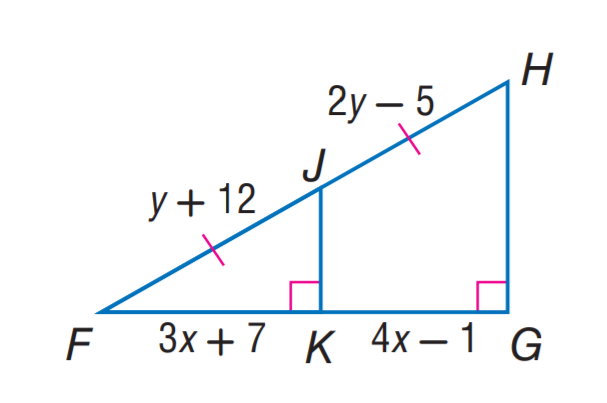Answer the mathemtical geometry problem and directly provide the correct option letter.
Question: Find y.
Choices: A: 7 B: 8 C: 12 D: 17 D 